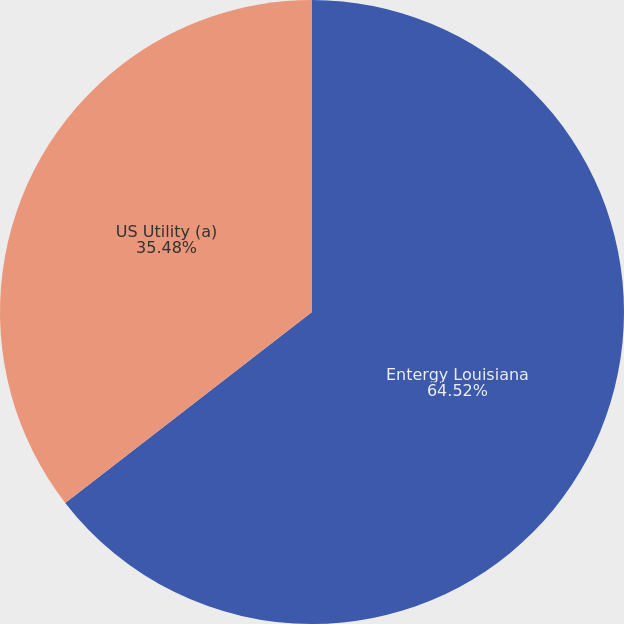Convert chart. <chart><loc_0><loc_0><loc_500><loc_500><pie_chart><fcel>Entergy Louisiana<fcel>US Utility (a)<nl><fcel>64.52%<fcel>35.48%<nl></chart> 